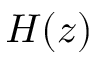<formula> <loc_0><loc_0><loc_500><loc_500>H ( z )</formula> 